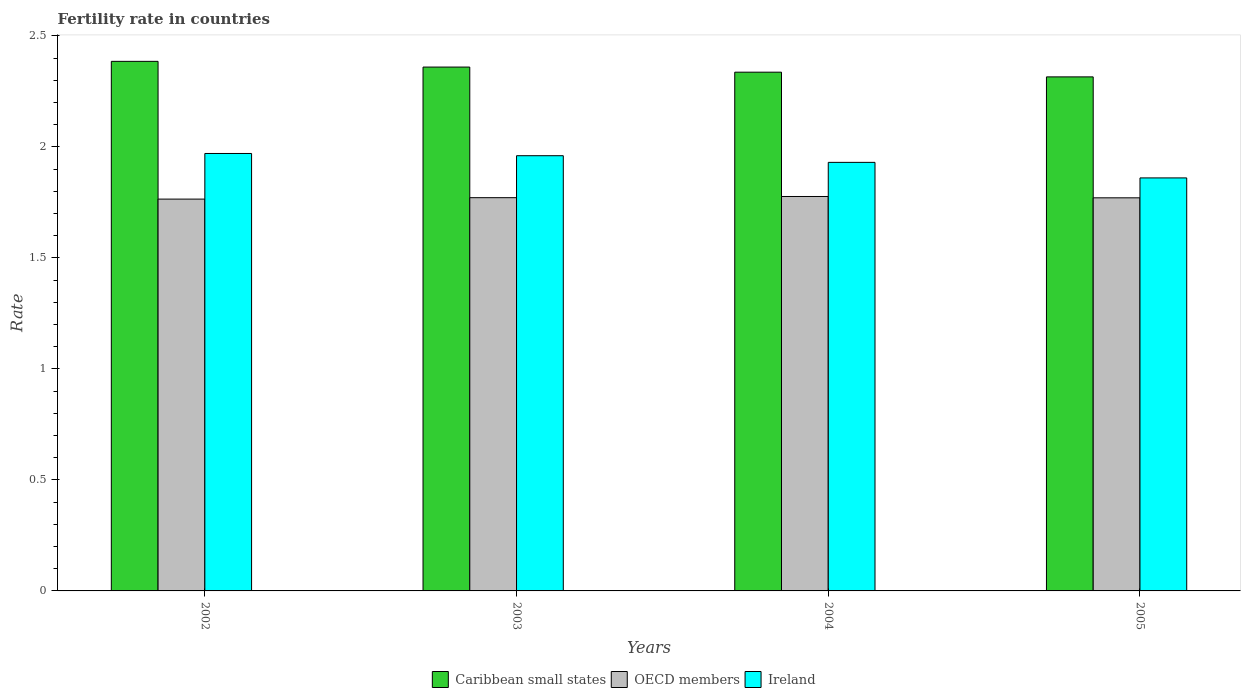How many different coloured bars are there?
Your response must be concise. 3. Are the number of bars per tick equal to the number of legend labels?
Give a very brief answer. Yes. Are the number of bars on each tick of the X-axis equal?
Provide a succinct answer. Yes. How many bars are there on the 2nd tick from the left?
Your answer should be very brief. 3. How many bars are there on the 3rd tick from the right?
Your answer should be compact. 3. In how many cases, is the number of bars for a given year not equal to the number of legend labels?
Offer a terse response. 0. What is the fertility rate in OECD members in 2005?
Offer a terse response. 1.77. Across all years, what is the maximum fertility rate in Caribbean small states?
Provide a succinct answer. 2.38. Across all years, what is the minimum fertility rate in Caribbean small states?
Your answer should be very brief. 2.31. In which year was the fertility rate in Ireland maximum?
Make the answer very short. 2002. What is the total fertility rate in Caribbean small states in the graph?
Make the answer very short. 9.4. What is the difference between the fertility rate in Ireland in 2002 and that in 2003?
Give a very brief answer. 0.01. What is the difference between the fertility rate in Ireland in 2003 and the fertility rate in OECD members in 2002?
Your answer should be compact. 0.2. What is the average fertility rate in OECD members per year?
Your response must be concise. 1.77. In the year 2002, what is the difference between the fertility rate in Caribbean small states and fertility rate in Ireland?
Offer a terse response. 0.41. What is the ratio of the fertility rate in Ireland in 2004 to that in 2005?
Provide a succinct answer. 1.04. Is the fertility rate in OECD members in 2002 less than that in 2004?
Provide a short and direct response. Yes. Is the difference between the fertility rate in Caribbean small states in 2003 and 2004 greater than the difference between the fertility rate in Ireland in 2003 and 2004?
Keep it short and to the point. No. What is the difference between the highest and the second highest fertility rate in Caribbean small states?
Ensure brevity in your answer.  0.03. What is the difference between the highest and the lowest fertility rate in Caribbean small states?
Your answer should be very brief. 0.07. What does the 2nd bar from the left in 2002 represents?
Your answer should be compact. OECD members. What does the 1st bar from the right in 2004 represents?
Your answer should be compact. Ireland. Is it the case that in every year, the sum of the fertility rate in Ireland and fertility rate in OECD members is greater than the fertility rate in Caribbean small states?
Ensure brevity in your answer.  Yes. How many years are there in the graph?
Offer a terse response. 4. What is the difference between two consecutive major ticks on the Y-axis?
Give a very brief answer. 0.5. Are the values on the major ticks of Y-axis written in scientific E-notation?
Your answer should be very brief. No. Does the graph contain any zero values?
Make the answer very short. No. Does the graph contain grids?
Make the answer very short. No. Where does the legend appear in the graph?
Keep it short and to the point. Bottom center. How are the legend labels stacked?
Your answer should be very brief. Horizontal. What is the title of the graph?
Your answer should be very brief. Fertility rate in countries. Does "Nigeria" appear as one of the legend labels in the graph?
Give a very brief answer. No. What is the label or title of the Y-axis?
Provide a short and direct response. Rate. What is the Rate of Caribbean small states in 2002?
Make the answer very short. 2.38. What is the Rate of OECD members in 2002?
Offer a terse response. 1.76. What is the Rate of Ireland in 2002?
Your answer should be very brief. 1.97. What is the Rate of Caribbean small states in 2003?
Your answer should be very brief. 2.36. What is the Rate of OECD members in 2003?
Keep it short and to the point. 1.77. What is the Rate of Ireland in 2003?
Provide a succinct answer. 1.96. What is the Rate in Caribbean small states in 2004?
Make the answer very short. 2.34. What is the Rate in OECD members in 2004?
Keep it short and to the point. 1.78. What is the Rate in Ireland in 2004?
Offer a terse response. 1.93. What is the Rate of Caribbean small states in 2005?
Offer a terse response. 2.31. What is the Rate in OECD members in 2005?
Give a very brief answer. 1.77. What is the Rate in Ireland in 2005?
Ensure brevity in your answer.  1.86. Across all years, what is the maximum Rate of Caribbean small states?
Offer a terse response. 2.38. Across all years, what is the maximum Rate in OECD members?
Your answer should be compact. 1.78. Across all years, what is the maximum Rate of Ireland?
Provide a succinct answer. 1.97. Across all years, what is the minimum Rate of Caribbean small states?
Provide a short and direct response. 2.31. Across all years, what is the minimum Rate of OECD members?
Offer a terse response. 1.76. Across all years, what is the minimum Rate in Ireland?
Make the answer very short. 1.86. What is the total Rate of Caribbean small states in the graph?
Offer a terse response. 9.4. What is the total Rate of OECD members in the graph?
Make the answer very short. 7.08. What is the total Rate in Ireland in the graph?
Your answer should be compact. 7.72. What is the difference between the Rate in Caribbean small states in 2002 and that in 2003?
Give a very brief answer. 0.03. What is the difference between the Rate in OECD members in 2002 and that in 2003?
Offer a terse response. -0.01. What is the difference between the Rate in Ireland in 2002 and that in 2003?
Your answer should be very brief. 0.01. What is the difference between the Rate in Caribbean small states in 2002 and that in 2004?
Provide a short and direct response. 0.05. What is the difference between the Rate of OECD members in 2002 and that in 2004?
Keep it short and to the point. -0.01. What is the difference between the Rate in Caribbean small states in 2002 and that in 2005?
Your answer should be very brief. 0.07. What is the difference between the Rate of OECD members in 2002 and that in 2005?
Provide a short and direct response. -0.01. What is the difference between the Rate of Ireland in 2002 and that in 2005?
Your answer should be compact. 0.11. What is the difference between the Rate of Caribbean small states in 2003 and that in 2004?
Ensure brevity in your answer.  0.02. What is the difference between the Rate in OECD members in 2003 and that in 2004?
Make the answer very short. -0.01. What is the difference between the Rate in Ireland in 2003 and that in 2004?
Your response must be concise. 0.03. What is the difference between the Rate of Caribbean small states in 2003 and that in 2005?
Your response must be concise. 0.04. What is the difference between the Rate of OECD members in 2003 and that in 2005?
Offer a terse response. 0. What is the difference between the Rate of Caribbean small states in 2004 and that in 2005?
Provide a succinct answer. 0.02. What is the difference between the Rate in OECD members in 2004 and that in 2005?
Give a very brief answer. 0.01. What is the difference between the Rate of Ireland in 2004 and that in 2005?
Make the answer very short. 0.07. What is the difference between the Rate in Caribbean small states in 2002 and the Rate in OECD members in 2003?
Offer a terse response. 0.61. What is the difference between the Rate in Caribbean small states in 2002 and the Rate in Ireland in 2003?
Your response must be concise. 0.42. What is the difference between the Rate of OECD members in 2002 and the Rate of Ireland in 2003?
Your response must be concise. -0.2. What is the difference between the Rate of Caribbean small states in 2002 and the Rate of OECD members in 2004?
Give a very brief answer. 0.61. What is the difference between the Rate of Caribbean small states in 2002 and the Rate of Ireland in 2004?
Give a very brief answer. 0.45. What is the difference between the Rate of OECD members in 2002 and the Rate of Ireland in 2004?
Your answer should be compact. -0.17. What is the difference between the Rate in Caribbean small states in 2002 and the Rate in OECD members in 2005?
Your answer should be compact. 0.61. What is the difference between the Rate of Caribbean small states in 2002 and the Rate of Ireland in 2005?
Your response must be concise. 0.52. What is the difference between the Rate of OECD members in 2002 and the Rate of Ireland in 2005?
Your answer should be very brief. -0.1. What is the difference between the Rate of Caribbean small states in 2003 and the Rate of OECD members in 2004?
Ensure brevity in your answer.  0.58. What is the difference between the Rate of Caribbean small states in 2003 and the Rate of Ireland in 2004?
Offer a terse response. 0.43. What is the difference between the Rate of OECD members in 2003 and the Rate of Ireland in 2004?
Offer a terse response. -0.16. What is the difference between the Rate of Caribbean small states in 2003 and the Rate of OECD members in 2005?
Your answer should be very brief. 0.59. What is the difference between the Rate in Caribbean small states in 2003 and the Rate in Ireland in 2005?
Provide a short and direct response. 0.5. What is the difference between the Rate of OECD members in 2003 and the Rate of Ireland in 2005?
Keep it short and to the point. -0.09. What is the difference between the Rate in Caribbean small states in 2004 and the Rate in OECD members in 2005?
Give a very brief answer. 0.57. What is the difference between the Rate of Caribbean small states in 2004 and the Rate of Ireland in 2005?
Your answer should be very brief. 0.48. What is the difference between the Rate in OECD members in 2004 and the Rate in Ireland in 2005?
Give a very brief answer. -0.08. What is the average Rate of Caribbean small states per year?
Keep it short and to the point. 2.35. What is the average Rate in OECD members per year?
Ensure brevity in your answer.  1.77. What is the average Rate of Ireland per year?
Make the answer very short. 1.93. In the year 2002, what is the difference between the Rate in Caribbean small states and Rate in OECD members?
Give a very brief answer. 0.62. In the year 2002, what is the difference between the Rate in Caribbean small states and Rate in Ireland?
Offer a terse response. 0.41. In the year 2002, what is the difference between the Rate of OECD members and Rate of Ireland?
Your answer should be compact. -0.21. In the year 2003, what is the difference between the Rate in Caribbean small states and Rate in OECD members?
Give a very brief answer. 0.59. In the year 2003, what is the difference between the Rate of Caribbean small states and Rate of Ireland?
Your answer should be very brief. 0.4. In the year 2003, what is the difference between the Rate of OECD members and Rate of Ireland?
Your answer should be very brief. -0.19. In the year 2004, what is the difference between the Rate in Caribbean small states and Rate in OECD members?
Your answer should be compact. 0.56. In the year 2004, what is the difference between the Rate in Caribbean small states and Rate in Ireland?
Offer a terse response. 0.41. In the year 2004, what is the difference between the Rate in OECD members and Rate in Ireland?
Give a very brief answer. -0.15. In the year 2005, what is the difference between the Rate of Caribbean small states and Rate of OECD members?
Offer a terse response. 0.54. In the year 2005, what is the difference between the Rate of Caribbean small states and Rate of Ireland?
Your answer should be compact. 0.46. In the year 2005, what is the difference between the Rate in OECD members and Rate in Ireland?
Offer a very short reply. -0.09. What is the ratio of the Rate in Caribbean small states in 2002 to that in 2003?
Your response must be concise. 1.01. What is the ratio of the Rate in Caribbean small states in 2002 to that in 2004?
Offer a very short reply. 1.02. What is the ratio of the Rate in Ireland in 2002 to that in 2004?
Your response must be concise. 1.02. What is the ratio of the Rate in Caribbean small states in 2002 to that in 2005?
Make the answer very short. 1.03. What is the ratio of the Rate in OECD members in 2002 to that in 2005?
Make the answer very short. 1. What is the ratio of the Rate of Ireland in 2002 to that in 2005?
Ensure brevity in your answer.  1.06. What is the ratio of the Rate of Caribbean small states in 2003 to that in 2004?
Give a very brief answer. 1.01. What is the ratio of the Rate in OECD members in 2003 to that in 2004?
Provide a short and direct response. 1. What is the ratio of the Rate in Ireland in 2003 to that in 2004?
Ensure brevity in your answer.  1.02. What is the ratio of the Rate of Caribbean small states in 2003 to that in 2005?
Ensure brevity in your answer.  1.02. What is the ratio of the Rate in OECD members in 2003 to that in 2005?
Make the answer very short. 1. What is the ratio of the Rate of Ireland in 2003 to that in 2005?
Keep it short and to the point. 1.05. What is the ratio of the Rate of Caribbean small states in 2004 to that in 2005?
Your answer should be compact. 1.01. What is the ratio of the Rate of Ireland in 2004 to that in 2005?
Offer a terse response. 1.04. What is the difference between the highest and the second highest Rate in Caribbean small states?
Your answer should be very brief. 0.03. What is the difference between the highest and the second highest Rate of OECD members?
Your answer should be compact. 0.01. What is the difference between the highest and the second highest Rate in Ireland?
Keep it short and to the point. 0.01. What is the difference between the highest and the lowest Rate of Caribbean small states?
Offer a very short reply. 0.07. What is the difference between the highest and the lowest Rate in OECD members?
Your answer should be very brief. 0.01. What is the difference between the highest and the lowest Rate of Ireland?
Offer a terse response. 0.11. 